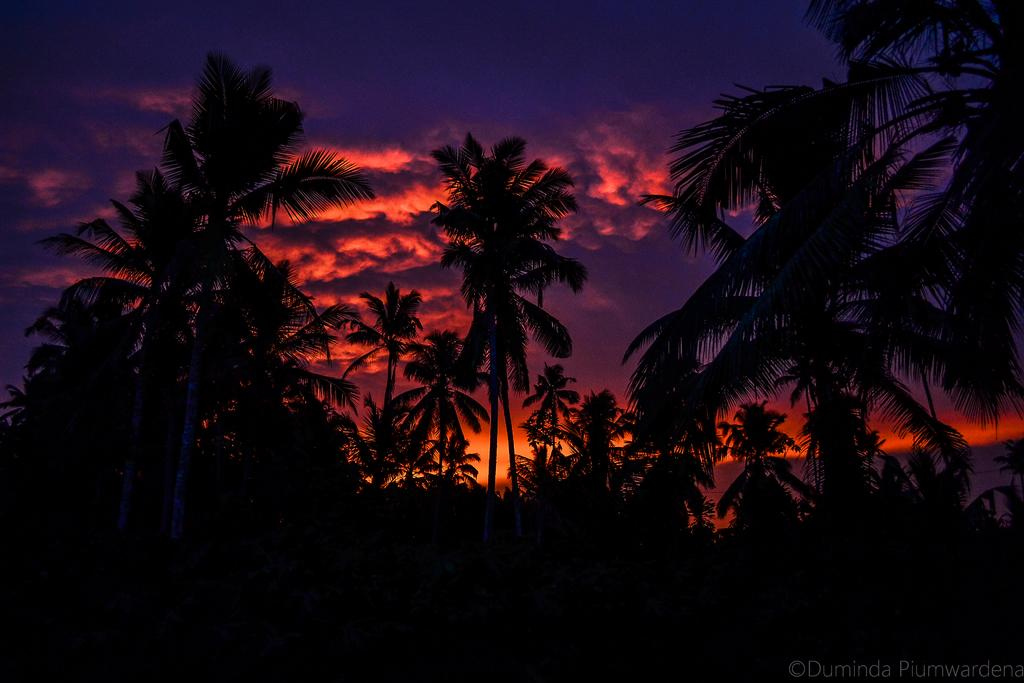What type of vegetation can be seen in the image? There are trees in the image. What part of the natural environment is visible in the image? The sky is visible in the background of the image. Where is the text located in the image? The text is in the bottom right corner of the image. What type of substance is being carried by the flock of birds in the image? There are no birds or substances present in the image; it only features trees and text. What type of locket can be seen hanging from the tree in the image? There is no locket present in the image; it only features trees and text. 